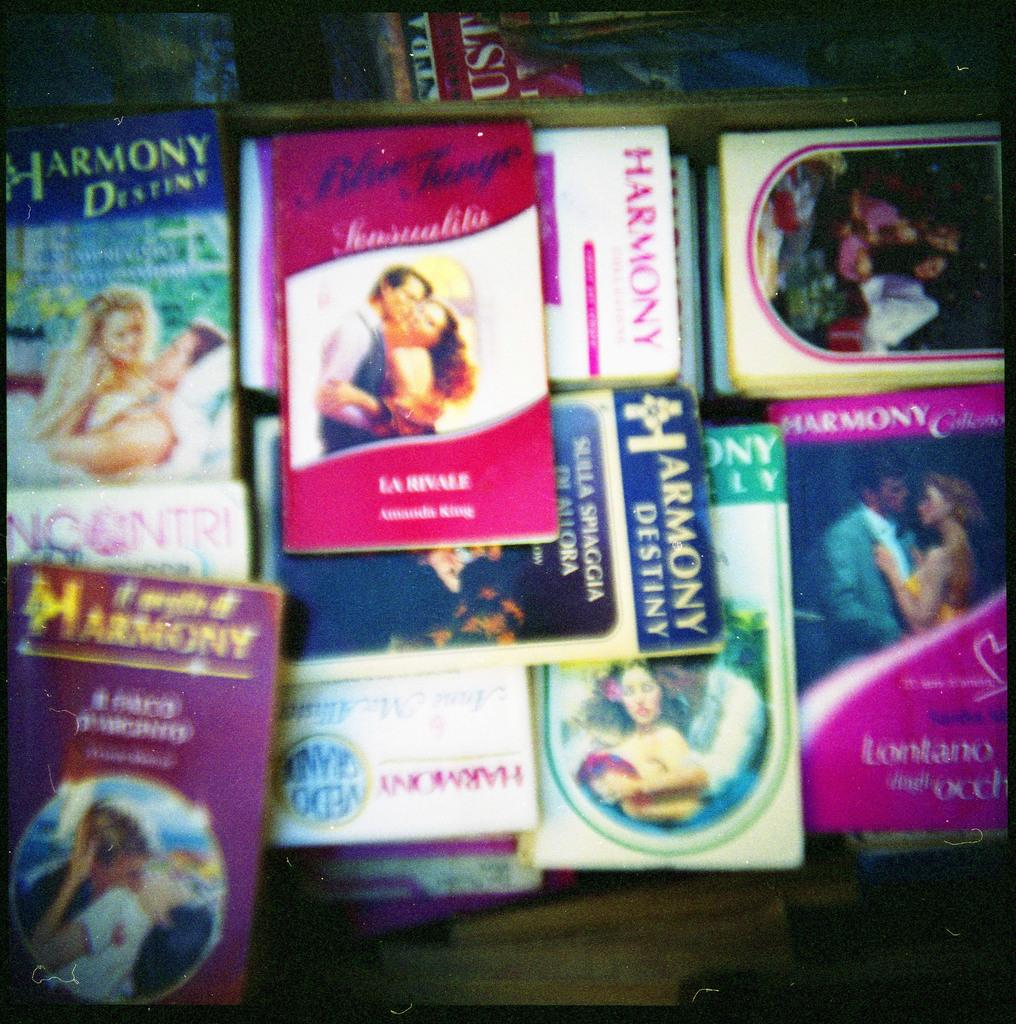<image>
Render a clear and concise summary of the photo. Many soft back romantic books in a pile, including some from the Harmony Destiny series. 